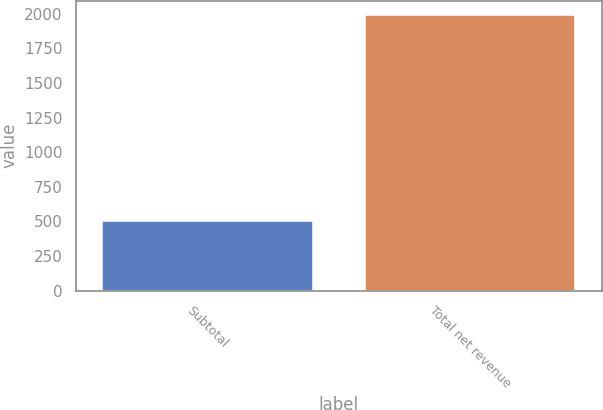Convert chart to OTSL. <chart><loc_0><loc_0><loc_500><loc_500><bar_chart><fcel>Subtotal<fcel>Total net revenue<nl><fcel>503<fcel>1993.1<nl></chart> 